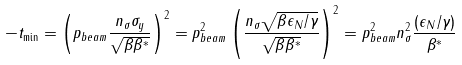<formula> <loc_0><loc_0><loc_500><loc_500>- t _ { \min } = \left ( p _ { b e a m } \frac { n _ { \sigma } \sigma _ { y } } { \sqrt { \beta \beta ^ { * } } } \right ) ^ { 2 } = p ^ { 2 } _ { b e a m } \left ( \frac { n _ { \sigma } \sqrt { \beta \epsilon _ { N } / \gamma } } { \sqrt { \beta \beta ^ { * } } } \right ) ^ { 2 } = p ^ { 2 } _ { b e a m } n ^ { 2 } _ { \sigma } \frac { \left ( \epsilon _ { N } / \gamma \right ) } { \beta ^ { * } }</formula> 